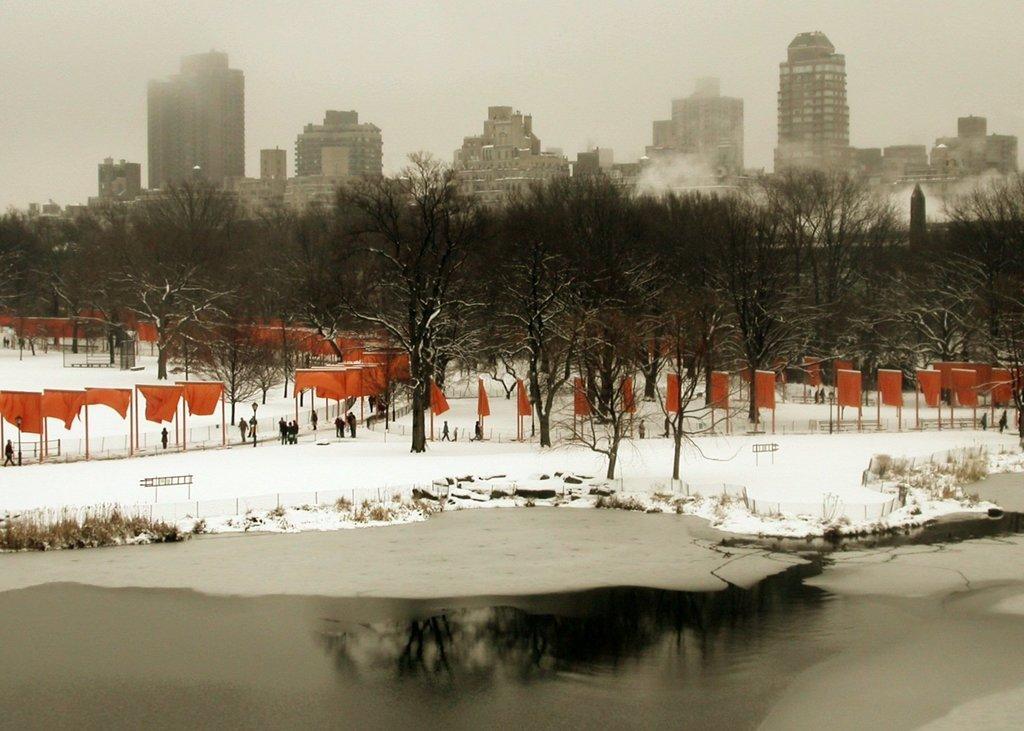In one or two sentences, can you explain what this image depicts? This picture is full of fog and snow. Here we can see flags in orange colour. We can see few persons walking and standing. These are the bare trees. At the top we can see sky. These are the buildings. Here we can see the reflection of trees on the road. 